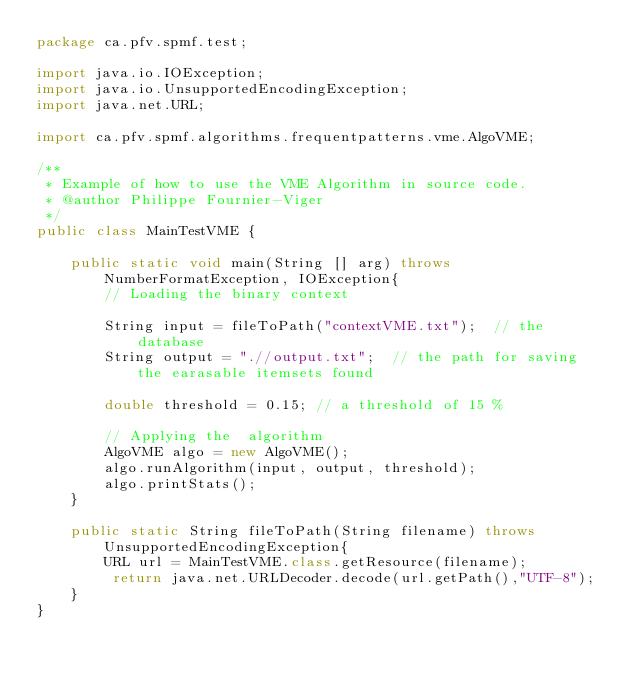Convert code to text. <code><loc_0><loc_0><loc_500><loc_500><_Java_>package ca.pfv.spmf.test;

import java.io.IOException;
import java.io.UnsupportedEncodingException;
import java.net.URL;

import ca.pfv.spmf.algorithms.frequentpatterns.vme.AlgoVME;

/**
 * Example of how to use the VME Algorithm in source code.
 * @author Philippe Fournier-Viger 
 */
public class MainTestVME {

	public static void main(String [] arg) throws NumberFormatException, IOException{
		// Loading the binary context
		
		String input = fileToPath("contextVME.txt");  // the database
		String output = ".//output.txt";  // the path for saving the earasable itemsets found
		
		double threshold = 0.15; // a threshold of 15 %
		
		// Applying the  algorithm
		AlgoVME algo = new AlgoVME();
		algo.runAlgorithm(input, output, threshold);
		algo.printStats();
	}
	
	public static String fileToPath(String filename) throws UnsupportedEncodingException{
		URL url = MainTestVME.class.getResource(filename);
		 return java.net.URLDecoder.decode(url.getPath(),"UTF-8");
	}
}
</code> 